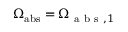<formula> <loc_0><loc_0><loc_500><loc_500>\Omega _ { a b s } = \Omega _ { a b s , 1 }</formula> 